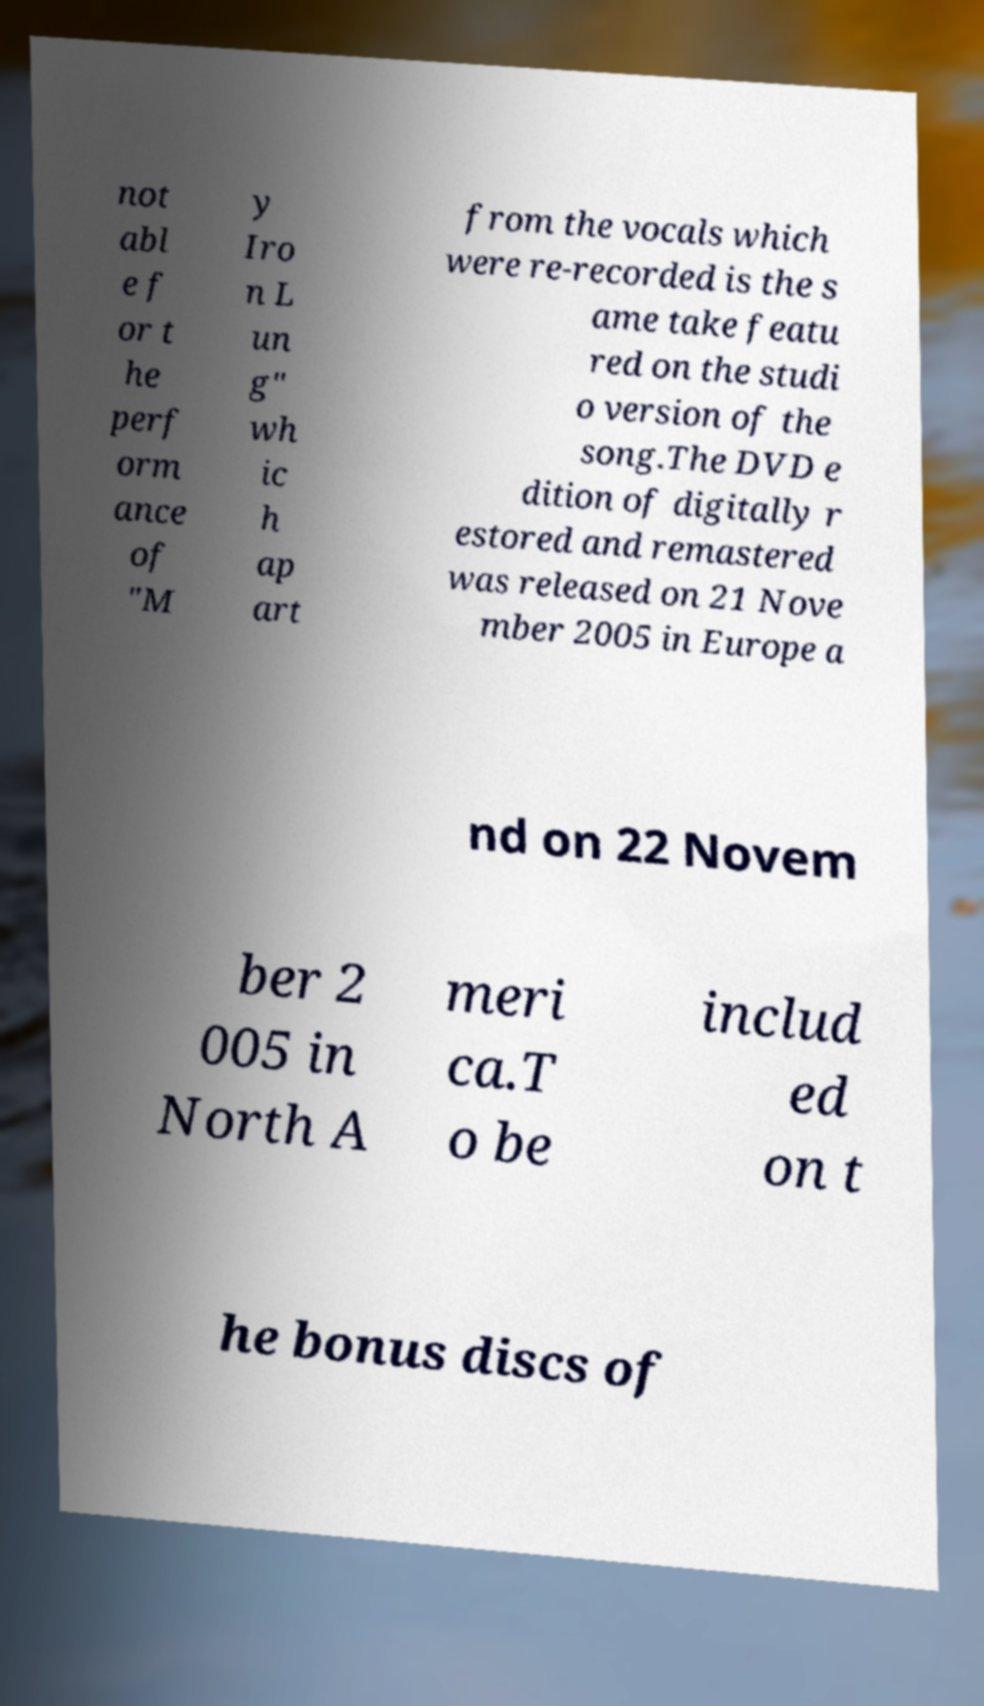I need the written content from this picture converted into text. Can you do that? not abl e f or t he perf orm ance of "M y Iro n L un g" wh ic h ap art from the vocals which were re-recorded is the s ame take featu red on the studi o version of the song.The DVD e dition of digitally r estored and remastered was released on 21 Nove mber 2005 in Europe a nd on 22 Novem ber 2 005 in North A meri ca.T o be includ ed on t he bonus discs of 